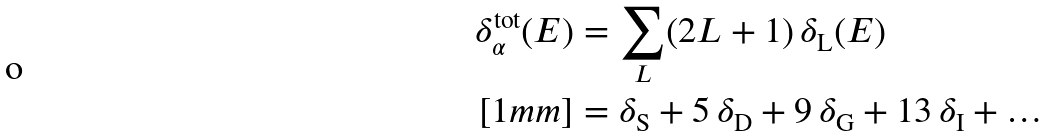Convert formula to latex. <formula><loc_0><loc_0><loc_500><loc_500>\delta ^ { \text {tot} } _ { \alpha } ( E ) & = \sum _ { L } ( 2 L + 1 ) \, \delta _ { \text {L} } ( E ) \\ [ 1 m m ] & = \delta _ { \text {S} } + 5 \, \delta _ { \text {D} } + 9 \, \delta _ { \text {G} } + 1 3 \, \delta _ { \text {I} } + \dots</formula> 